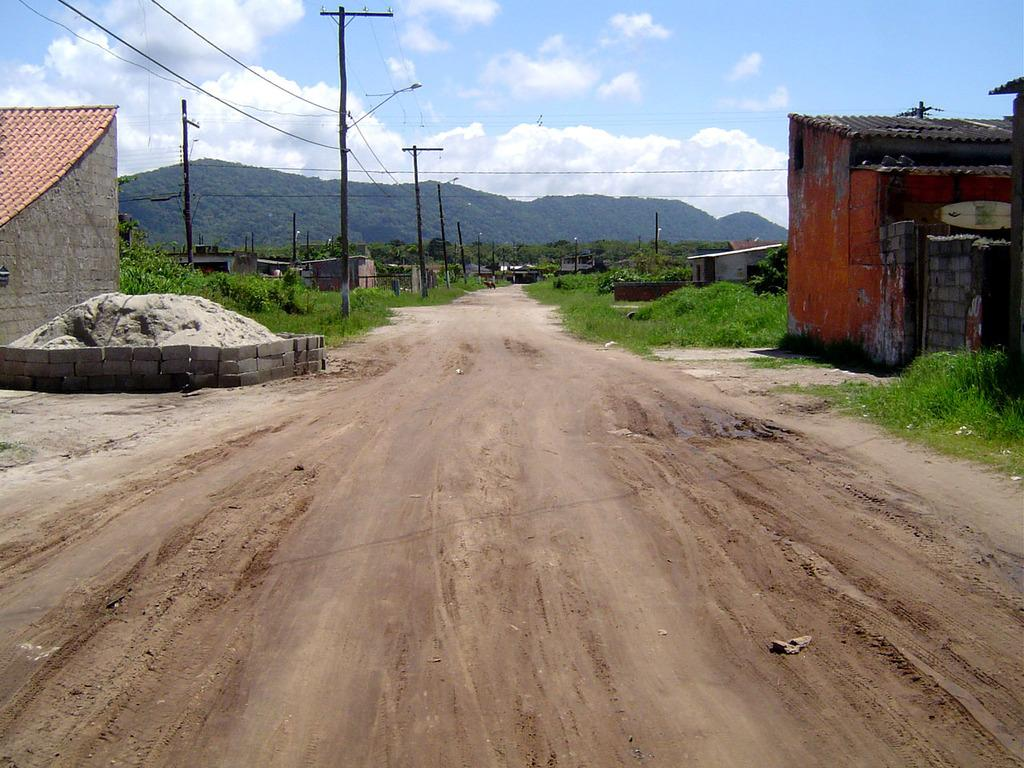What type of structures can be seen in the image? There are houses in the image. What else can be seen attached to poles in the image? There are wires attached to poles in the image. What type of lighting is present in the image? There are street lights in the image. What type of vegetation is visible in the image? There is grass and trees visible in the image. What can be seen in the background of the image? There are mountains and the sky visible in the background of the image. Where is the bag hanging on the tree in the image? There is no bag hanging on a tree in the image. What type of button can be seen on the mountain in the image? There is no button present on the mountain in the image. 